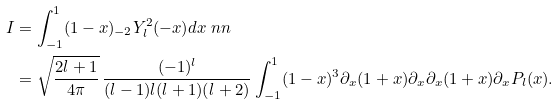Convert formula to latex. <formula><loc_0><loc_0><loc_500><loc_500>I & = \int _ { - 1 } ^ { 1 } ( 1 - x ) _ { - 2 } Y _ { l } ^ { 2 } ( - x ) d x \ n n \\ & = \sqrt { \frac { 2 l + 1 } { 4 \pi } } \, \frac { ( - 1 ) ^ { l } } { ( l - 1 ) l ( l + 1 ) ( l + 2 ) } \int _ { - 1 } ^ { 1 } ( 1 - x ) ^ { 3 } \partial _ { x } ( 1 + x ) \partial _ { x } \partial _ { x } ( 1 + x ) \partial _ { x } P _ { l } ( x ) .</formula> 